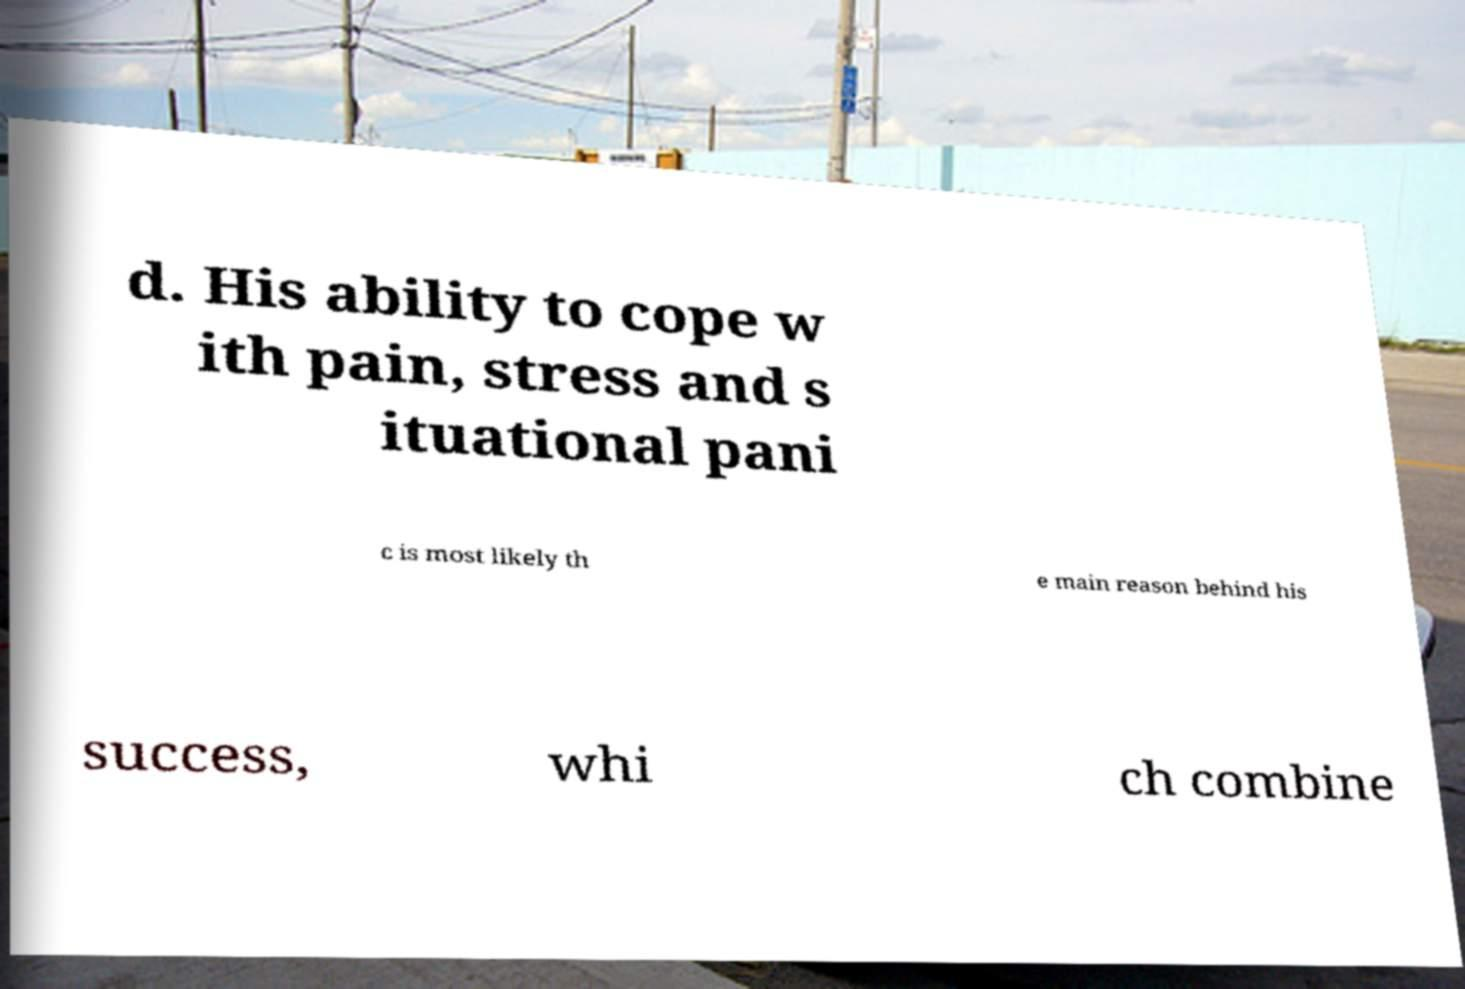I need the written content from this picture converted into text. Can you do that? d. His ability to cope w ith pain, stress and s ituational pani c is most likely th e main reason behind his success, whi ch combine 